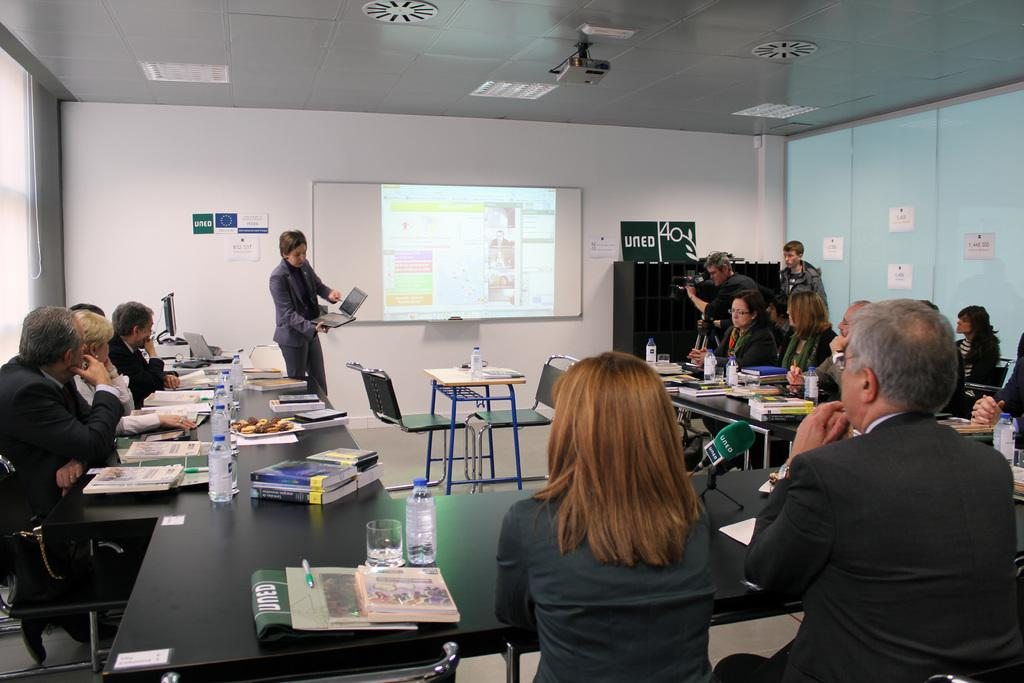How many people are in the image? There is a group of people in the image, but the exact number is not specified. What are the people in the image doing? Some people are sitting, while others are standing. What can be seen attached to the ceiling in the image? There is a projector attached to the ceiling. What is the purpose of the projector screen in the image? The projector screen is likely used for displaying images or presentations during a meeting or event. What type of root is growing out of the projector screen in the image? There is no root growing out of the projector screen in the image. What ingredients are used to make the stew that is being served in the image? There is no stew present in the image. 